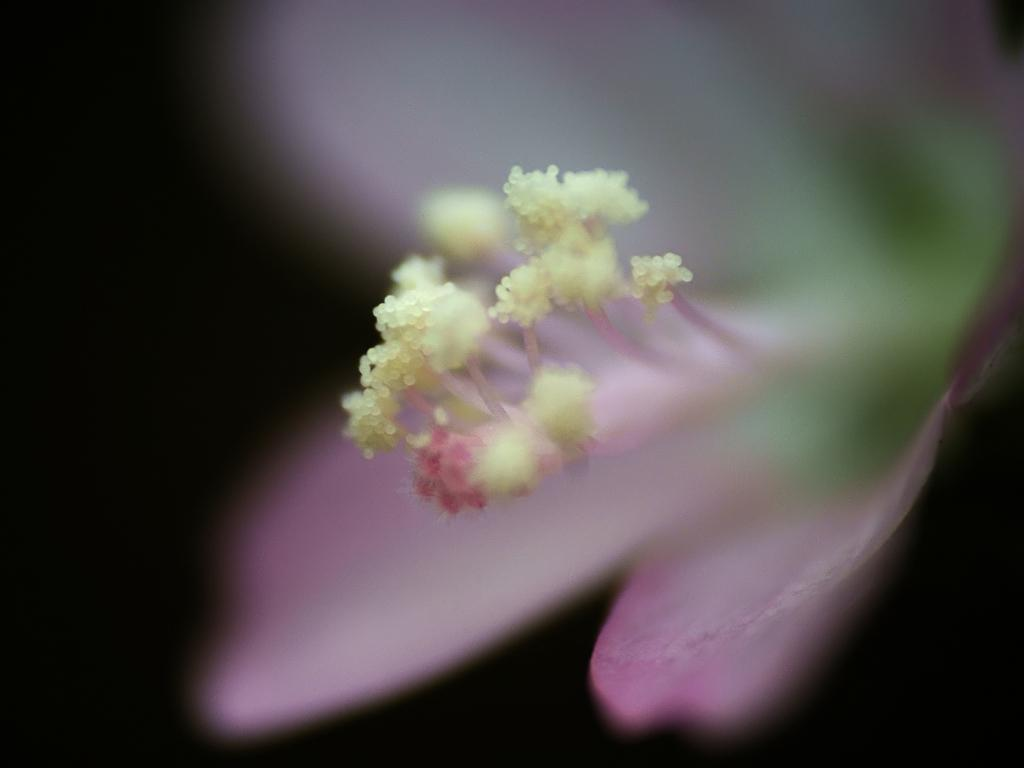What is the main subject of the image? There is a flower in the image. Can you describe the colors of the flower? The flower has pink, green, and yellow colors. What is the color of the background in the image? The background of the image is black. How does the flower's flesh affect its temper in the image? There is no mention of the flower having flesh or temper in the image, as it is a still image of a flower with specific colors. 